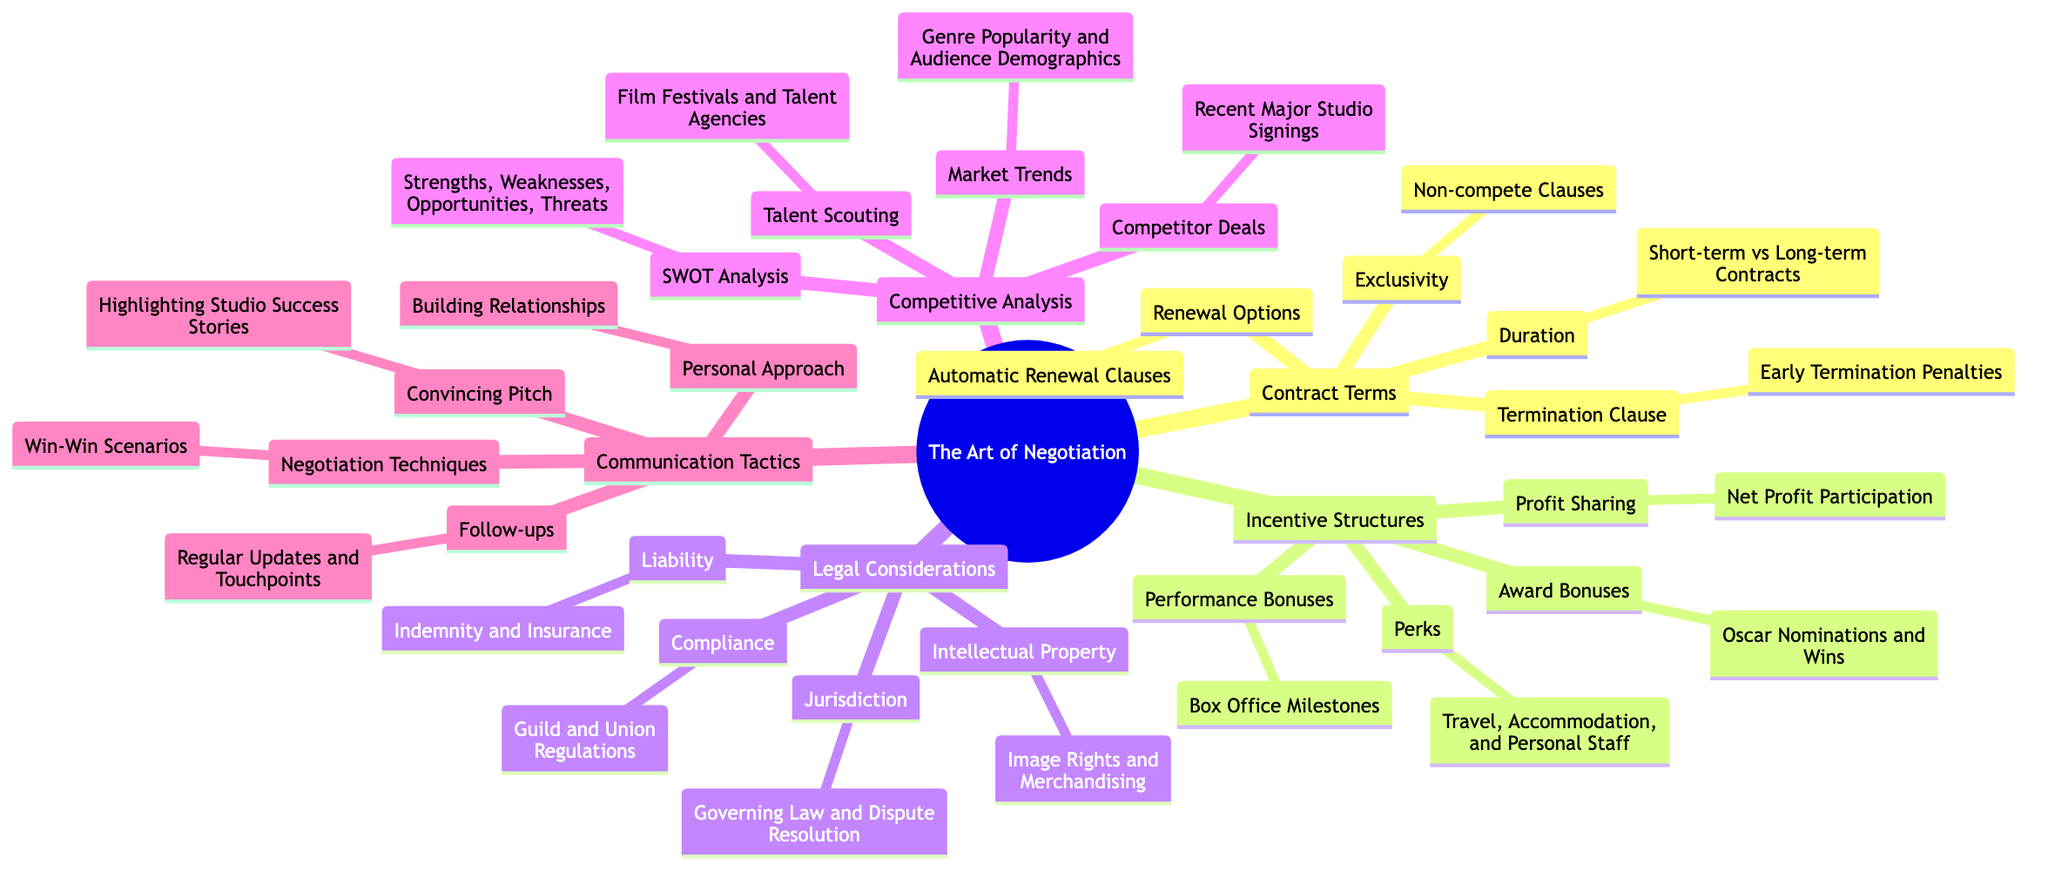What are the categories under "The Art of Negotiation"? The main categories are visible as first-level branches in the mind map stemming from the root. They include "Contract Terms," "Incentive Structures," "Legal Considerations," "Competitive Analysis," and "Communication Tactics."
Answer: Contract Terms, Incentive Structures, Legal Considerations, Competitive Analysis, Communication Tactics How many subtopics are under "Incentive Structures"? By counting the visible nodes branching off from "Incentive Structures," we find that there are four distinct subtopics: "Performance Bonuses," "Profit Sharing," "Award Bonuses," and "Perks."
Answer: 4 What does "Termination Clause" encompass? Looking under the "Contract Terms" category, "Termination Clause" contains a specific subtopic: "Early Termination Penalties," which details consequences associated with ending a contract early.
Answer: Early Termination Penalties Which structure relates to "Jurisdiction"? "Jurisdiction" falls under "Legal Considerations" and is connected to further details such as "Governing Law and Dispute Resolution," capturing essential elements of legal negotiation.
Answer: Governing Law and Dispute Resolution What are the performance incentives listed? Exploring "Incentive Structures," we find four categories of performance incentives: "Performance Bonuses," "Profit Sharing," "Award Bonuses," and "Perks," which motivate the talent effectively.
Answer: Performance Bonuses, Profit Sharing, Award Bonuses, Perks What is the first level node related to "Building Relationships"? "Building Relationships" is a subtopic that branches from "Personal Approach," which itself is part of the overarching category "Communication Tactics."
Answer: Personal Approach How does "Competitive Analysis" inform "Talent Scouting"? "Talent Scouting" appears as a subtopic under "Competitive Analysis," suggesting that it involves evaluating talent through platforms like film festivals and agencies, ultimately influencing scouting efforts.
Answer: Film Festivals and Talent Agencies What incentive is tied to "Oscar Nominations and Wins"? This particular incentive falls under "Award Bonuses" in the "Incentive Structures" section, highlighting the motivational aspects of prestigious awards to secure talent.
Answer: Award Bonuses Which two aspects fall under "Intellectual Property"? Under "Legal Considerations," "Intellectual Property" includes "Image Rights and Merchandising," showing a clear link between artistic works and their commercial implications.
Answer: Image Rights and Merchandising 